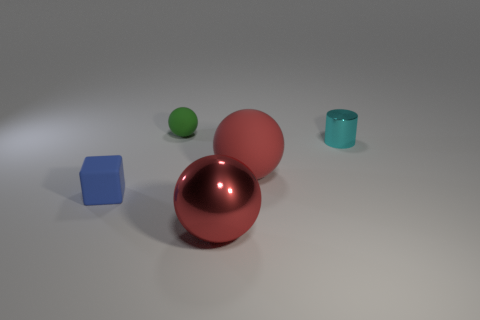What is the light source in the image? The light source isn't directly visible in the image, but based on the shadows and highlights, it appears to be coming from the upper left, casting soft shadows on the right side of the objects. 